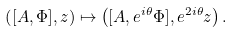Convert formula to latex. <formula><loc_0><loc_0><loc_500><loc_500>\left ( [ A , \Phi ] , z \right ) \mapsto \left ( [ A , e ^ { i \theta } \Phi ] , e ^ { 2 i \theta } z \right ) .</formula> 